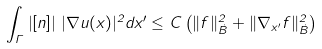<formula> <loc_0><loc_0><loc_500><loc_500>\int _ { \Gamma } \left | [ n ] \right | \, | \nabla u ( x ) | ^ { 2 } d x ^ { \prime } \leq C \left ( \| f \| _ { \dot { B } } ^ { 2 } + \| \nabla _ { x ^ { \prime } } f \| _ { \dot { B } } ^ { 2 } \right )</formula> 